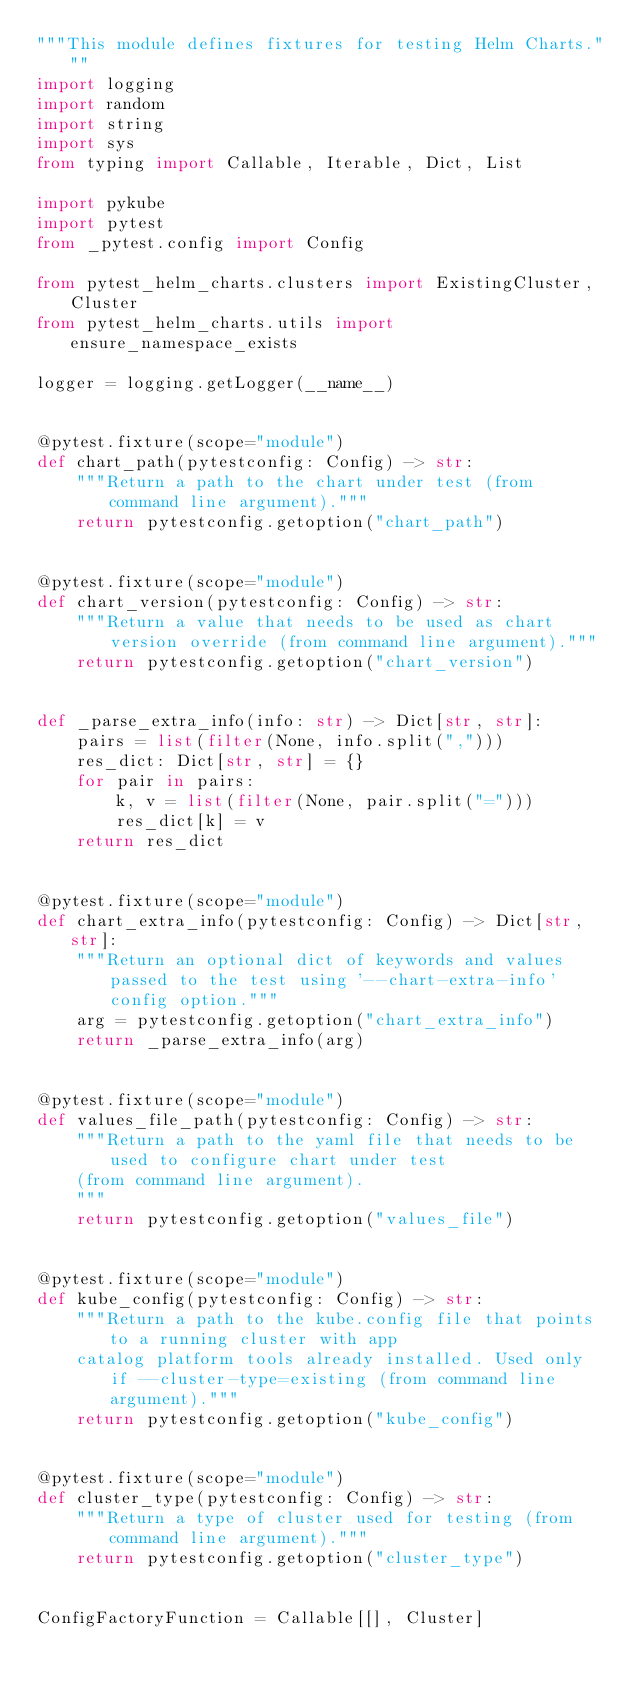Convert code to text. <code><loc_0><loc_0><loc_500><loc_500><_Python_>"""This module defines fixtures for testing Helm Charts."""
import logging
import random
import string
import sys
from typing import Callable, Iterable, Dict, List

import pykube
import pytest
from _pytest.config import Config

from pytest_helm_charts.clusters import ExistingCluster, Cluster
from pytest_helm_charts.utils import ensure_namespace_exists

logger = logging.getLogger(__name__)


@pytest.fixture(scope="module")
def chart_path(pytestconfig: Config) -> str:
    """Return a path to the chart under test (from command line argument)."""
    return pytestconfig.getoption("chart_path")


@pytest.fixture(scope="module")
def chart_version(pytestconfig: Config) -> str:
    """Return a value that needs to be used as chart version override (from command line argument)."""
    return pytestconfig.getoption("chart_version")


def _parse_extra_info(info: str) -> Dict[str, str]:
    pairs = list(filter(None, info.split(",")))
    res_dict: Dict[str, str] = {}
    for pair in pairs:
        k, v = list(filter(None, pair.split("=")))
        res_dict[k] = v
    return res_dict


@pytest.fixture(scope="module")
def chart_extra_info(pytestconfig: Config) -> Dict[str, str]:
    """Return an optional dict of keywords and values passed to the test using '--chart-extra-info' config option."""
    arg = pytestconfig.getoption("chart_extra_info")
    return _parse_extra_info(arg)


@pytest.fixture(scope="module")
def values_file_path(pytestconfig: Config) -> str:
    """Return a path to the yaml file that needs to be used to configure chart under test
    (from command line argument).
    """
    return pytestconfig.getoption("values_file")


@pytest.fixture(scope="module")
def kube_config(pytestconfig: Config) -> str:
    """Return a path to the kube.config file that points to a running cluster with app
    catalog platform tools already installed. Used only if --cluster-type=existing (from command line argument)."""
    return pytestconfig.getoption("kube_config")


@pytest.fixture(scope="module")
def cluster_type(pytestconfig: Config) -> str:
    """Return a type of cluster used for testing (from command line argument)."""
    return pytestconfig.getoption("cluster_type")


ConfigFactoryFunction = Callable[[], Cluster]

</code> 